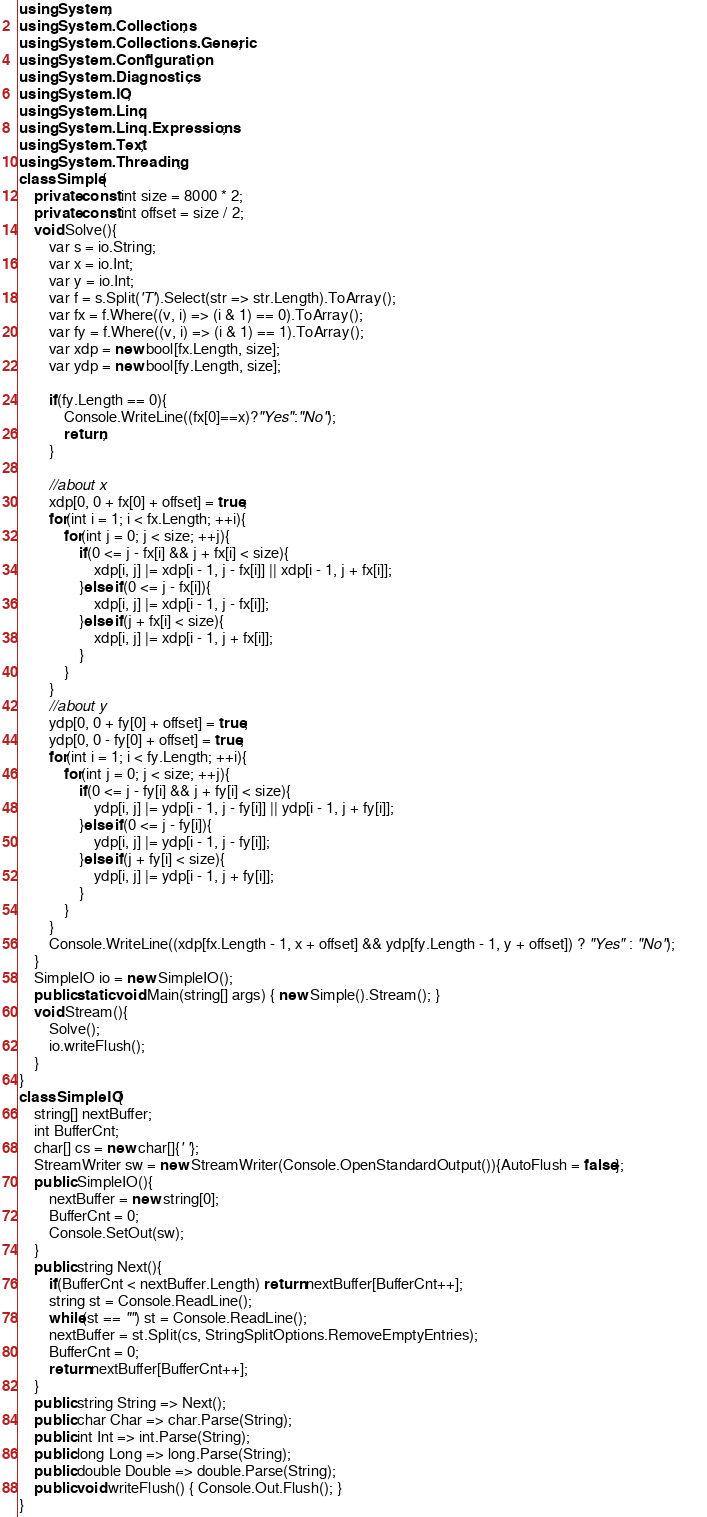Convert code to text. <code><loc_0><loc_0><loc_500><loc_500><_C#_>using System;
using System.Collections;
using System.Collections.Generic;
using System.Configuration;
using System.Diagnostics;
using System.IO;
using System.Linq;
using System.Linq.Expressions;
using System.Text;
using System.Threading;
class Simple{
    private const int size = 8000 * 2;
    private const int offset = size / 2;
    void Solve(){
        var s = io.String;
        var x = io.Int;
        var y = io.Int;
        var f = s.Split('T').Select(str => str.Length).ToArray();
        var fx = f.Where((v, i) => (i & 1) == 0).ToArray();
        var fy = f.Where((v, i) => (i & 1) == 1).ToArray();
        var xdp = new bool[fx.Length, size];
        var ydp = new bool[fy.Length, size];       
        
        if(fy.Length == 0){
            Console.WriteLine((fx[0]==x)?"Yes":"No");
            return;            
        }         
        
        //about x
        xdp[0, 0 + fx[0] + offset] = true;
        for(int i = 1; i < fx.Length; ++i){
            for(int j = 0; j < size; ++j){
                if(0 <= j - fx[i] && j + fx[i] < size){
                    xdp[i, j] |= xdp[i - 1, j - fx[i]] || xdp[i - 1, j + fx[i]];                    
                }else if(0 <= j - fx[i]){
                    xdp[i, j] |= xdp[i - 1, j - fx[i]];                     
                }else if(j + fx[i] < size){
                    xdp[i, j] |= xdp[i - 1, j + fx[i]];
                }
            }
        }
        //about y
        ydp[0, 0 + fy[0] + offset] = true;
        ydp[0, 0 - fy[0] + offset] = true;
        for(int i = 1; i < fy.Length; ++i){
            for(int j = 0; j < size; ++j){
                if(0 <= j - fy[i] && j + fy[i] < size){
                    ydp[i, j] |= ydp[i - 1, j - fy[i]] || ydp[i - 1, j + fy[i]];                    
                }else if(0 <= j - fy[i]){
                    ydp[i, j] |= ydp[i - 1, j - fy[i]];                     
                }else if(j + fy[i] < size){
                    ydp[i, j] |= ydp[i - 1, j + fy[i]];
                }
            }
        }       
        Console.WriteLine((xdp[fx.Length - 1, x + offset] && ydp[fy.Length - 1, y + offset]) ? "Yes" : "No");        
    }
    SimpleIO io = new SimpleIO();
    public static void Main(string[] args) { new Simple().Stream(); }
    void Stream(){
        Solve();
        io.writeFlush();
    }
}
class SimpleIO{
    string[] nextBuffer;
    int BufferCnt;
    char[] cs = new char[]{' '};
    StreamWriter sw = new StreamWriter(Console.OpenStandardOutput()){AutoFlush = false};
    public SimpleIO(){
        nextBuffer = new string[0];
        BufferCnt = 0;
        Console.SetOut(sw);
    }
    public string Next(){
        if(BufferCnt < nextBuffer.Length) return nextBuffer[BufferCnt++];
        string st = Console.ReadLine();
        while(st == "") st = Console.ReadLine();
        nextBuffer = st.Split(cs, StringSplitOptions.RemoveEmptyEntries);
        BufferCnt = 0;
        return nextBuffer[BufferCnt++];
    }
    public string String => Next();
    public char Char => char.Parse(String);
    public int Int => int.Parse(String);
    public long Long => long.Parse(String);
    public double Double => double.Parse(String);
    public void writeFlush() { Console.Out.Flush(); }
}
</code> 